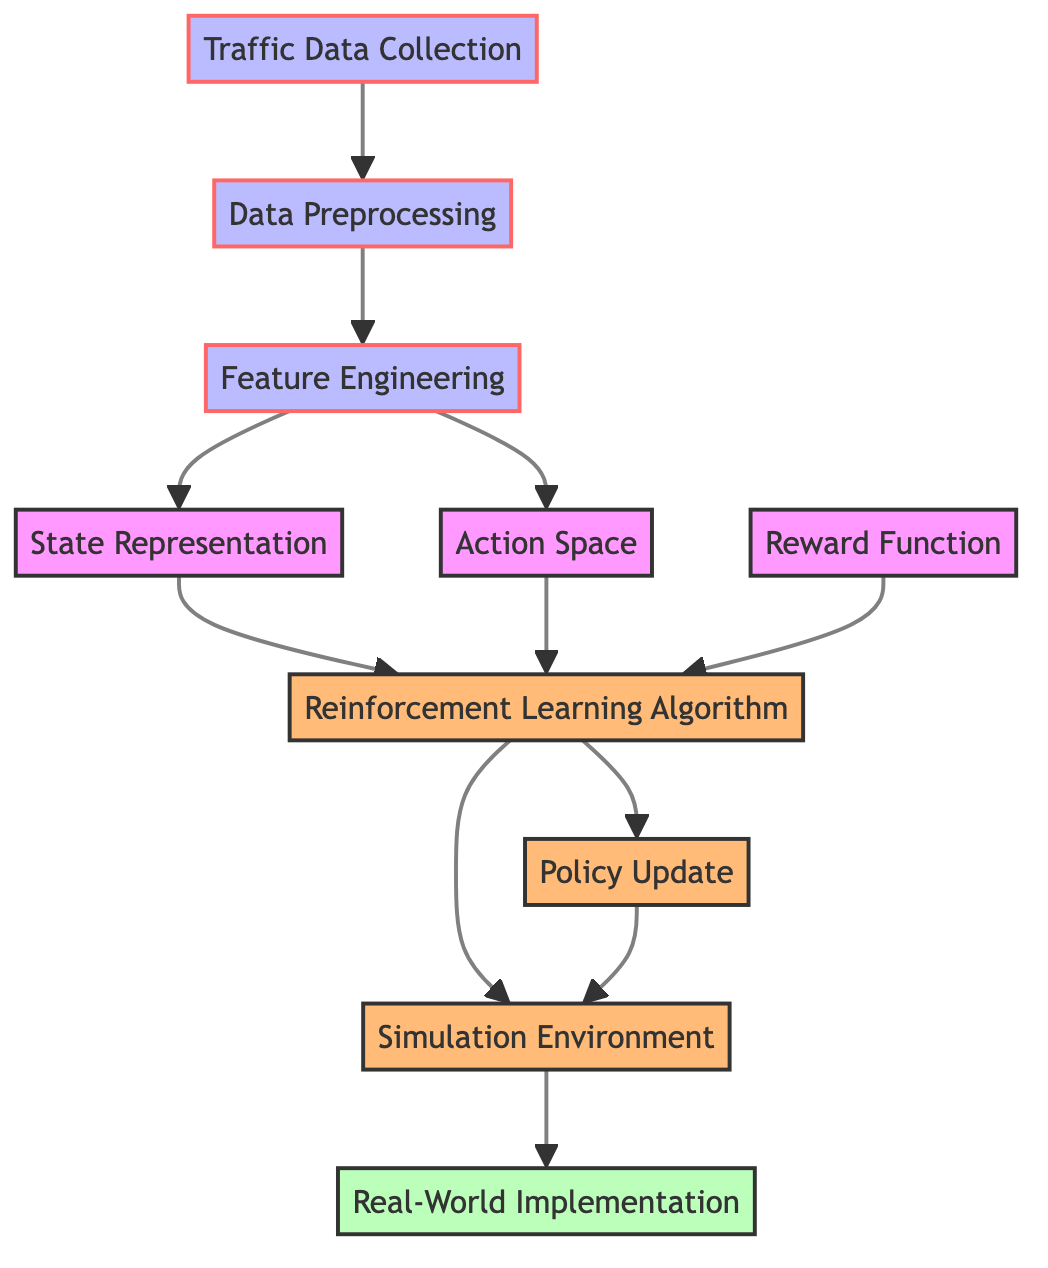What is the first step in the diagram? The first step in the diagram is "Traffic Data Collection," as indicated by the starting node pointing to the subsequent process.
Answer: Traffic Data Collection How many nodes are there in total? By counting each unique step and the representation of states/actions in the diagram, I determine that there are ten distinct nodes present.
Answer: 10 What is the last step in the diagram? The last step is labeled "Real-World Implementation," which is the final destination in the flow of processes.
Answer: Real-World Implementation Which two nodes connect to the Reinforcement Learning Algorithm node? The Reinforcement Learning Algorithm node receives input from both "State Representation" and "Action Space," as shown by the directed edges from these nodes to it.
Answer: State Representation and Action Space What is the purpose of the Reward Function in this diagram? The Reward Function is essential as it contributes to the Reinforcement Learning Algorithm, providing feedback for decision-making in the traffic flow optimization process.
Answer: Feedback for decision-making What type of class is the Policy Update node categorized under? The Policy Update node is classified as an "action" node, as indicated by the class assignment in the diagram.
Answer: Action Which step follows the Policy Update node? Following the Policy Update node, the next step in the flow is the "Simulation Environment," as represented by the directed edge leading from Policy Update to this node.
Answer: Simulation Environment How many processes are categorized as "process" nodes in the diagram? There are three nodes categorized as "process," specifically "Traffic Data Collection," "Data Preprocessing," and "Feature Engineering," based on the class definitions highlighted in the diagram.
Answer: 3 What connects the Reward Function to the Reinforcement Learning Algorithm? The Reward Function connects to the Reinforcement Learning Algorithm through a direct edge or arrow that signifies the flow of information or influence between these two components in the optimization process.
Answer: Direct edge (arrow) 